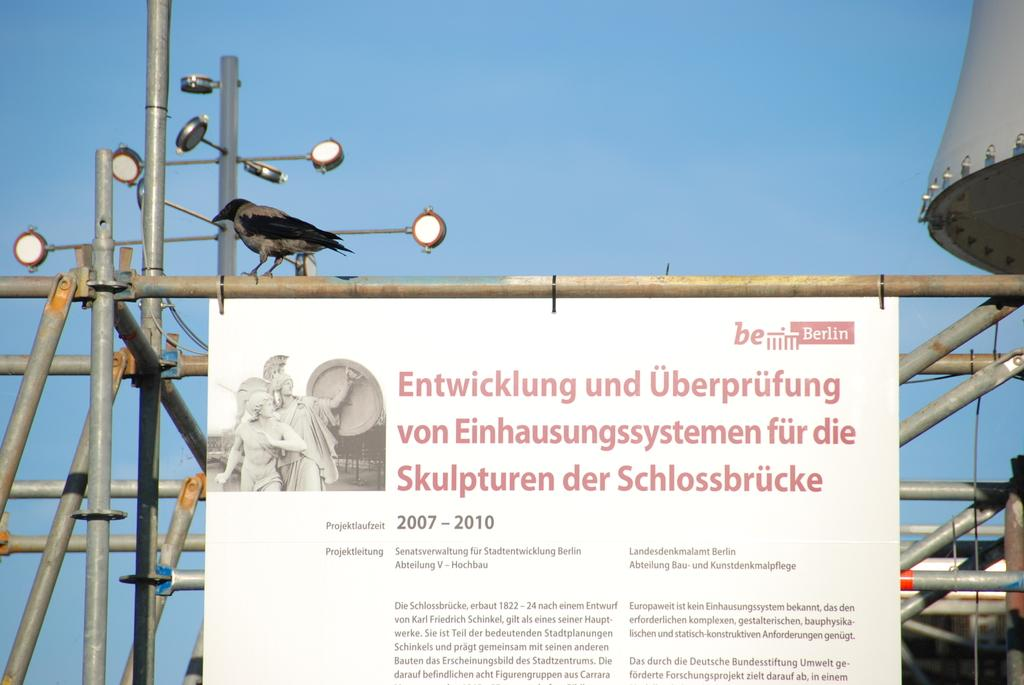Provide a one-sentence caption for the provided image. A white board with red lettering in Geman posted to a metal pole. 